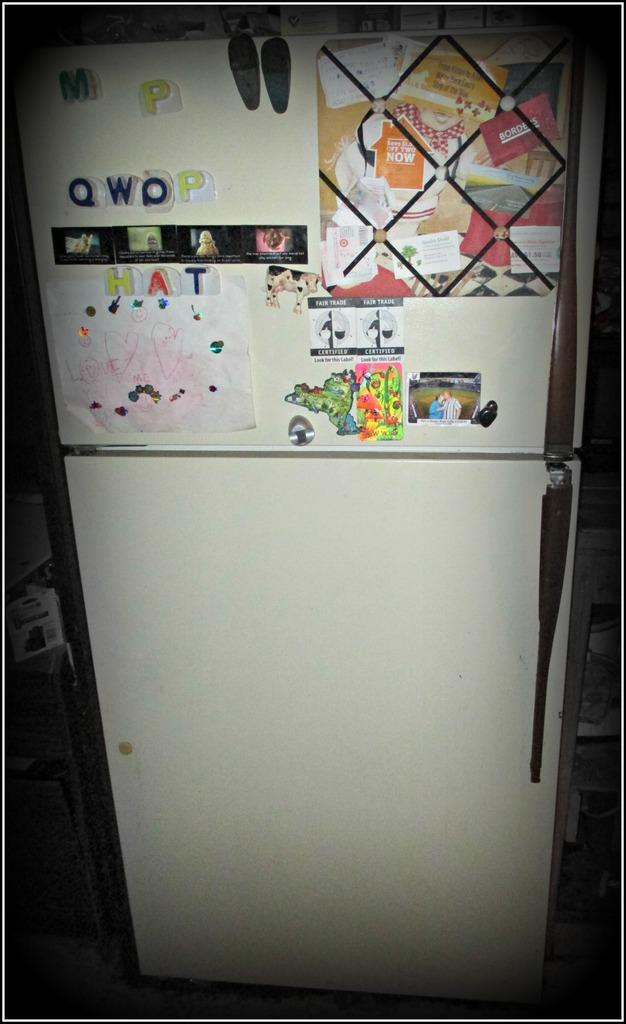<image>
Relay a brief, clear account of the picture shown. A fridge with pictures and magnets that spell out hat and qwop on it. 